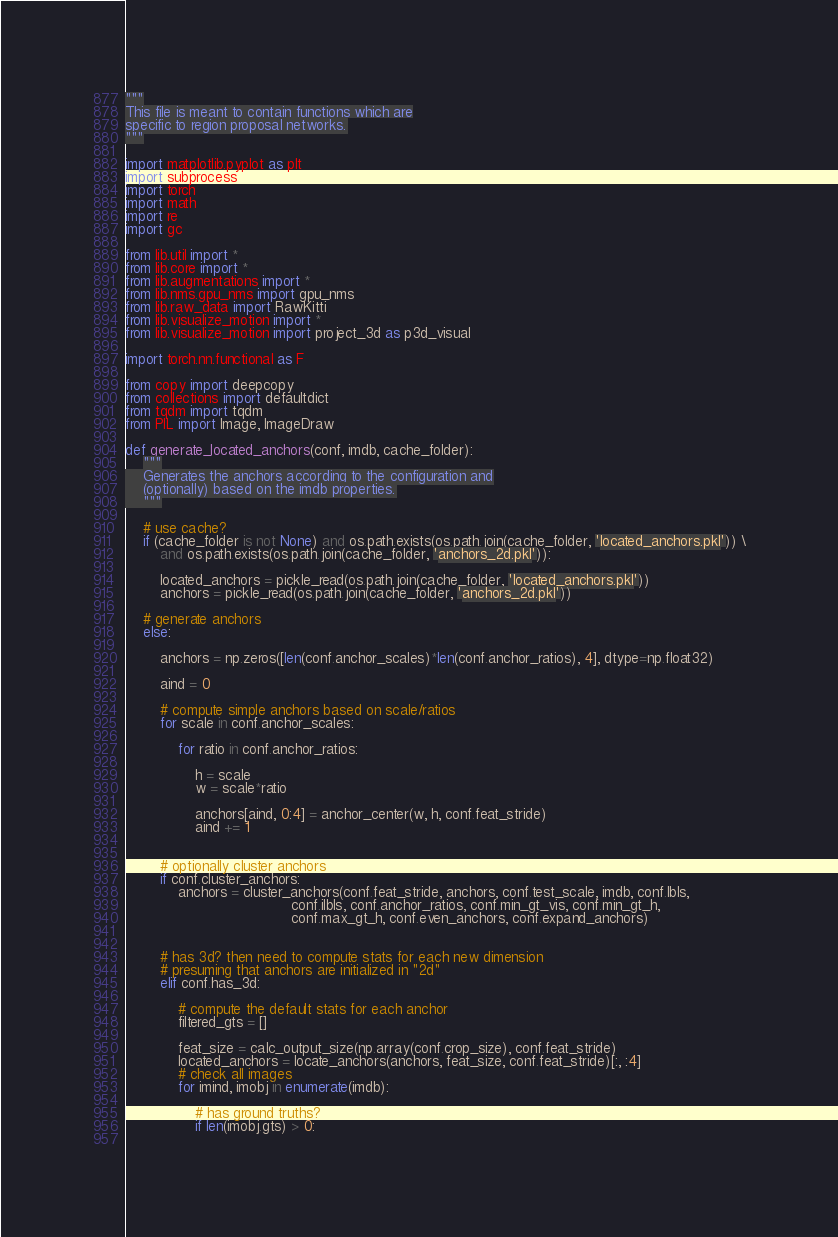Convert code to text. <code><loc_0><loc_0><loc_500><loc_500><_Python_>"""
This file is meant to contain functions which are
specific to region proposal networks.
"""

import matplotlib.pyplot as plt
import subprocess
import torch
import math
import re
import gc

from lib.util import *
from lib.core import *
from lib.augmentations import *
from lib.nms.gpu_nms import gpu_nms
from lib.raw_data import RawKitti
from lib.visualize_motion import *
from lib.visualize_motion import project_3d as p3d_visual

import torch.nn.functional as F

from copy import deepcopy
from collections import defaultdict
from tqdm import tqdm
from PIL import Image, ImageDraw

def generate_located_anchors(conf, imdb, cache_folder):
    """
    Generates the anchors according to the configuration and
    (optionally) based on the imdb properties.
    """

    # use cache?
    if (cache_folder is not None) and os.path.exists(os.path.join(cache_folder, 'located_anchors.pkl')) \
        and os.path.exists(os.path.join(cache_folder, 'anchors_2d.pkl')):

        located_anchors = pickle_read(os.path.join(cache_folder, 'located_anchors.pkl'))
        anchors = pickle_read(os.path.join(cache_folder, 'anchors_2d.pkl'))

    # generate anchors
    else:

        anchors = np.zeros([len(conf.anchor_scales)*len(conf.anchor_ratios), 4], dtype=np.float32)

        aind = 0

        # compute simple anchors based on scale/ratios
        for scale in conf.anchor_scales:

            for ratio in conf.anchor_ratios:

                h = scale
                w = scale*ratio

                anchors[aind, 0:4] = anchor_center(w, h, conf.feat_stride)
                aind += 1


        # optionally cluster anchors
        if conf.cluster_anchors:
            anchors = cluster_anchors(conf.feat_stride, anchors, conf.test_scale, imdb, conf.lbls,
                                      conf.ilbls, conf.anchor_ratios, conf.min_gt_vis, conf.min_gt_h,
                                      conf.max_gt_h, conf.even_anchors, conf.expand_anchors)

        
        # has 3d? then need to compute stats for each new dimension
        # presuming that anchors are initialized in "2d"
        elif conf.has_3d:

            # compute the default stats for each anchor
            filtered_gts = []

            feat_size = calc_output_size(np.array(conf.crop_size), conf.feat_stride)
            located_anchors = locate_anchors(anchors, feat_size, conf.feat_stride)[:, :4]
            # check all images
            for imind, imobj in enumerate(imdb):
    
                # has ground truths?
                if len(imobj.gts) > 0:
    </code> 